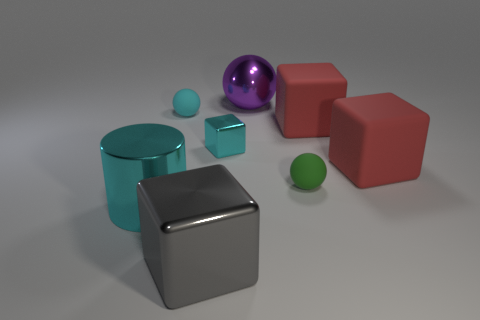Add 1 tiny cyan objects. How many objects exist? 9 Subtract all cylinders. How many objects are left? 7 Add 7 small brown objects. How many small brown objects exist? 7 Subtract 0 green cylinders. How many objects are left? 8 Subtract all tiny yellow cylinders. Subtract all large rubber objects. How many objects are left? 6 Add 5 small metallic things. How many small metallic things are left? 6 